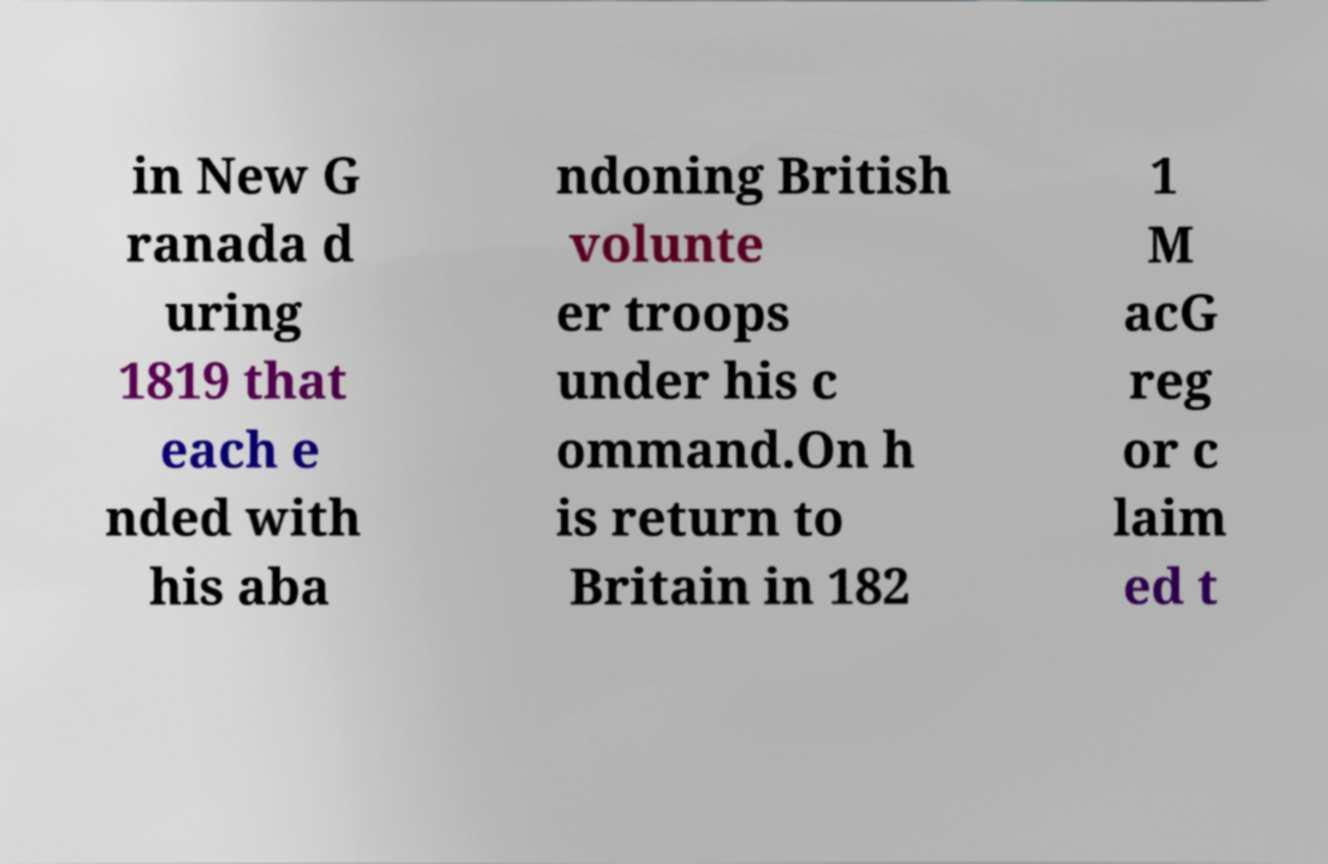For documentation purposes, I need the text within this image transcribed. Could you provide that? in New G ranada d uring 1819 that each e nded with his aba ndoning British volunte er troops under his c ommand.On h is return to Britain in 182 1 M acG reg or c laim ed t 